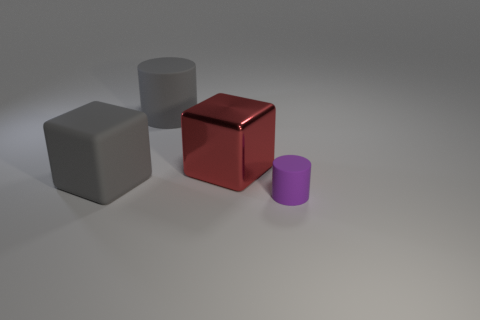How many tiny blue shiny objects are the same shape as the large red object?
Provide a succinct answer. 0. Is the number of metal objects that are behind the large red block the same as the number of gray cylinders?
Your answer should be very brief. No. There is a matte cylinder that is the same size as the gray cube; what is its color?
Offer a very short reply. Gray. Are there any small yellow shiny things of the same shape as the big red thing?
Give a very brief answer. No. What material is the gray object that is on the right side of the big matte thing that is in front of the big thing behind the large red object made of?
Offer a very short reply. Rubber. Are there the same number of rubber cylinders and small green balls?
Provide a short and direct response. No. How many other objects are there of the same size as the gray block?
Your response must be concise. 2. What color is the tiny object?
Your response must be concise. Purple. How many rubber things are either large red cubes or big gray cylinders?
Provide a succinct answer. 1. Are there any other things that are made of the same material as the tiny purple thing?
Your answer should be very brief. Yes. 